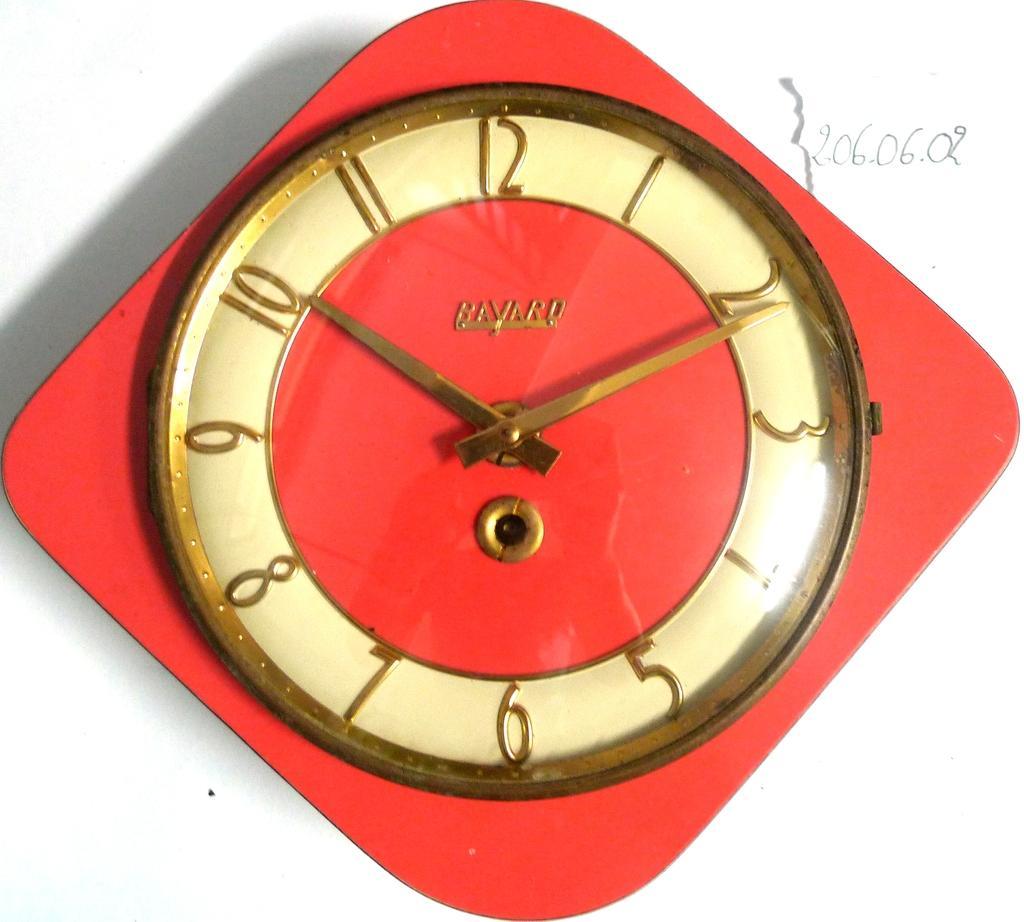How would you summarize this image in a sentence or two? There is a red clock on the white background. 